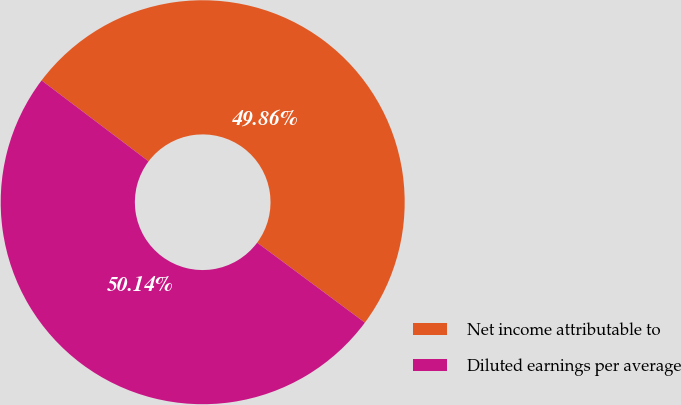Convert chart to OTSL. <chart><loc_0><loc_0><loc_500><loc_500><pie_chart><fcel>Net income attributable to<fcel>Diluted earnings per average<nl><fcel>49.86%<fcel>50.14%<nl></chart> 